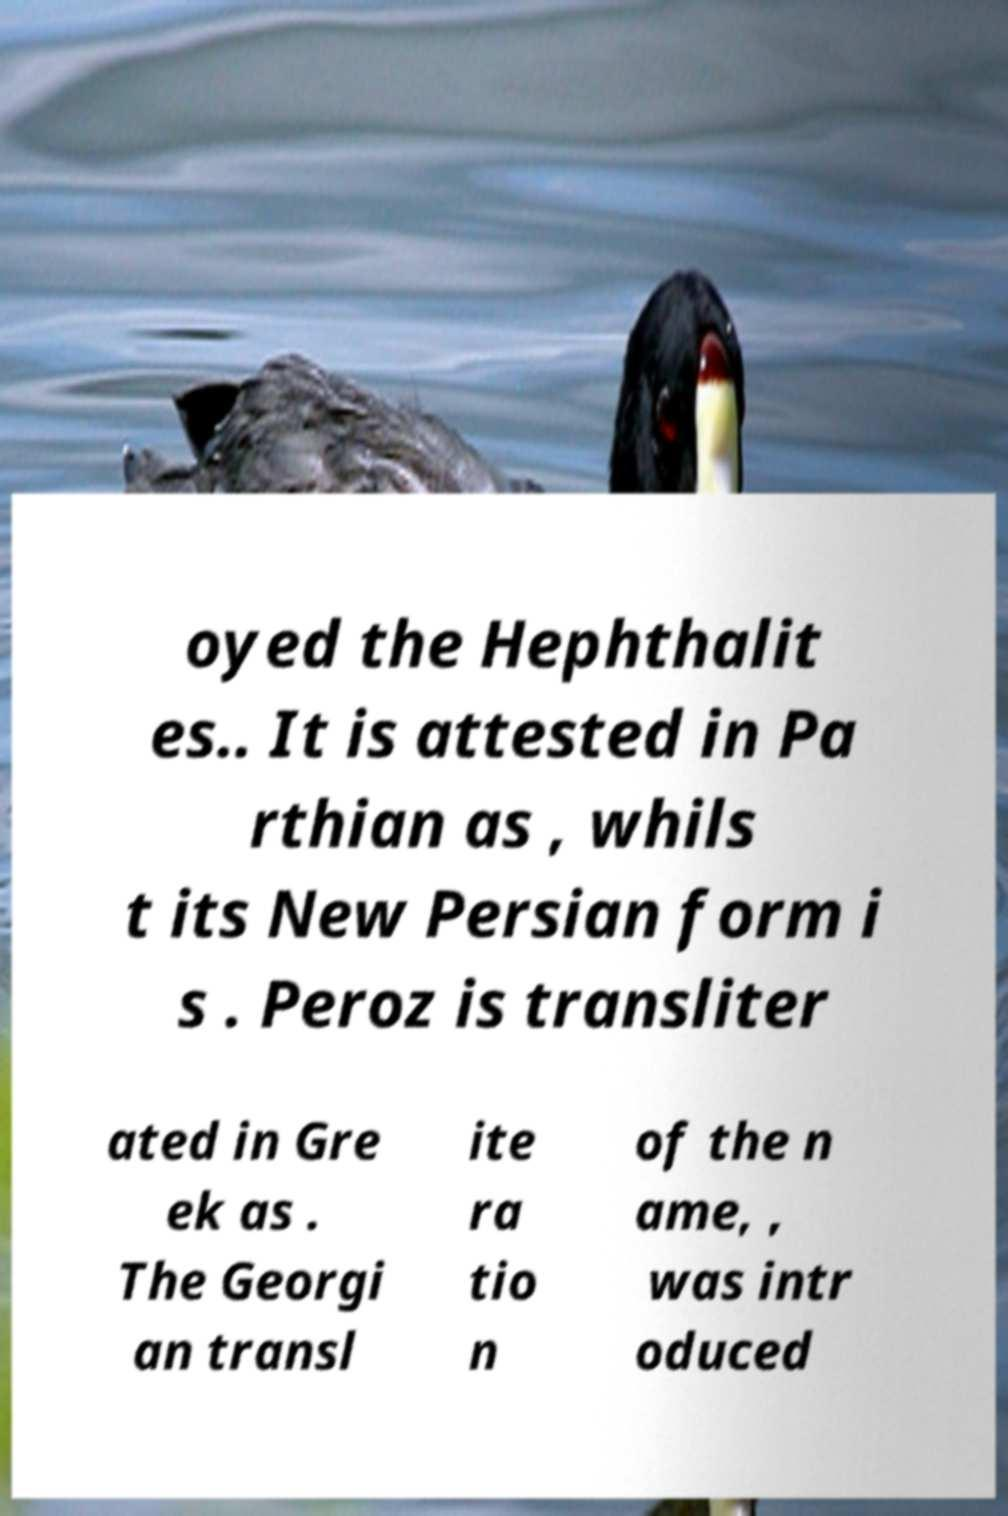Please identify and transcribe the text found in this image. oyed the Hephthalit es.. It is attested in Pa rthian as , whils t its New Persian form i s . Peroz is transliter ated in Gre ek as . The Georgi an transl ite ra tio n of the n ame, , was intr oduced 